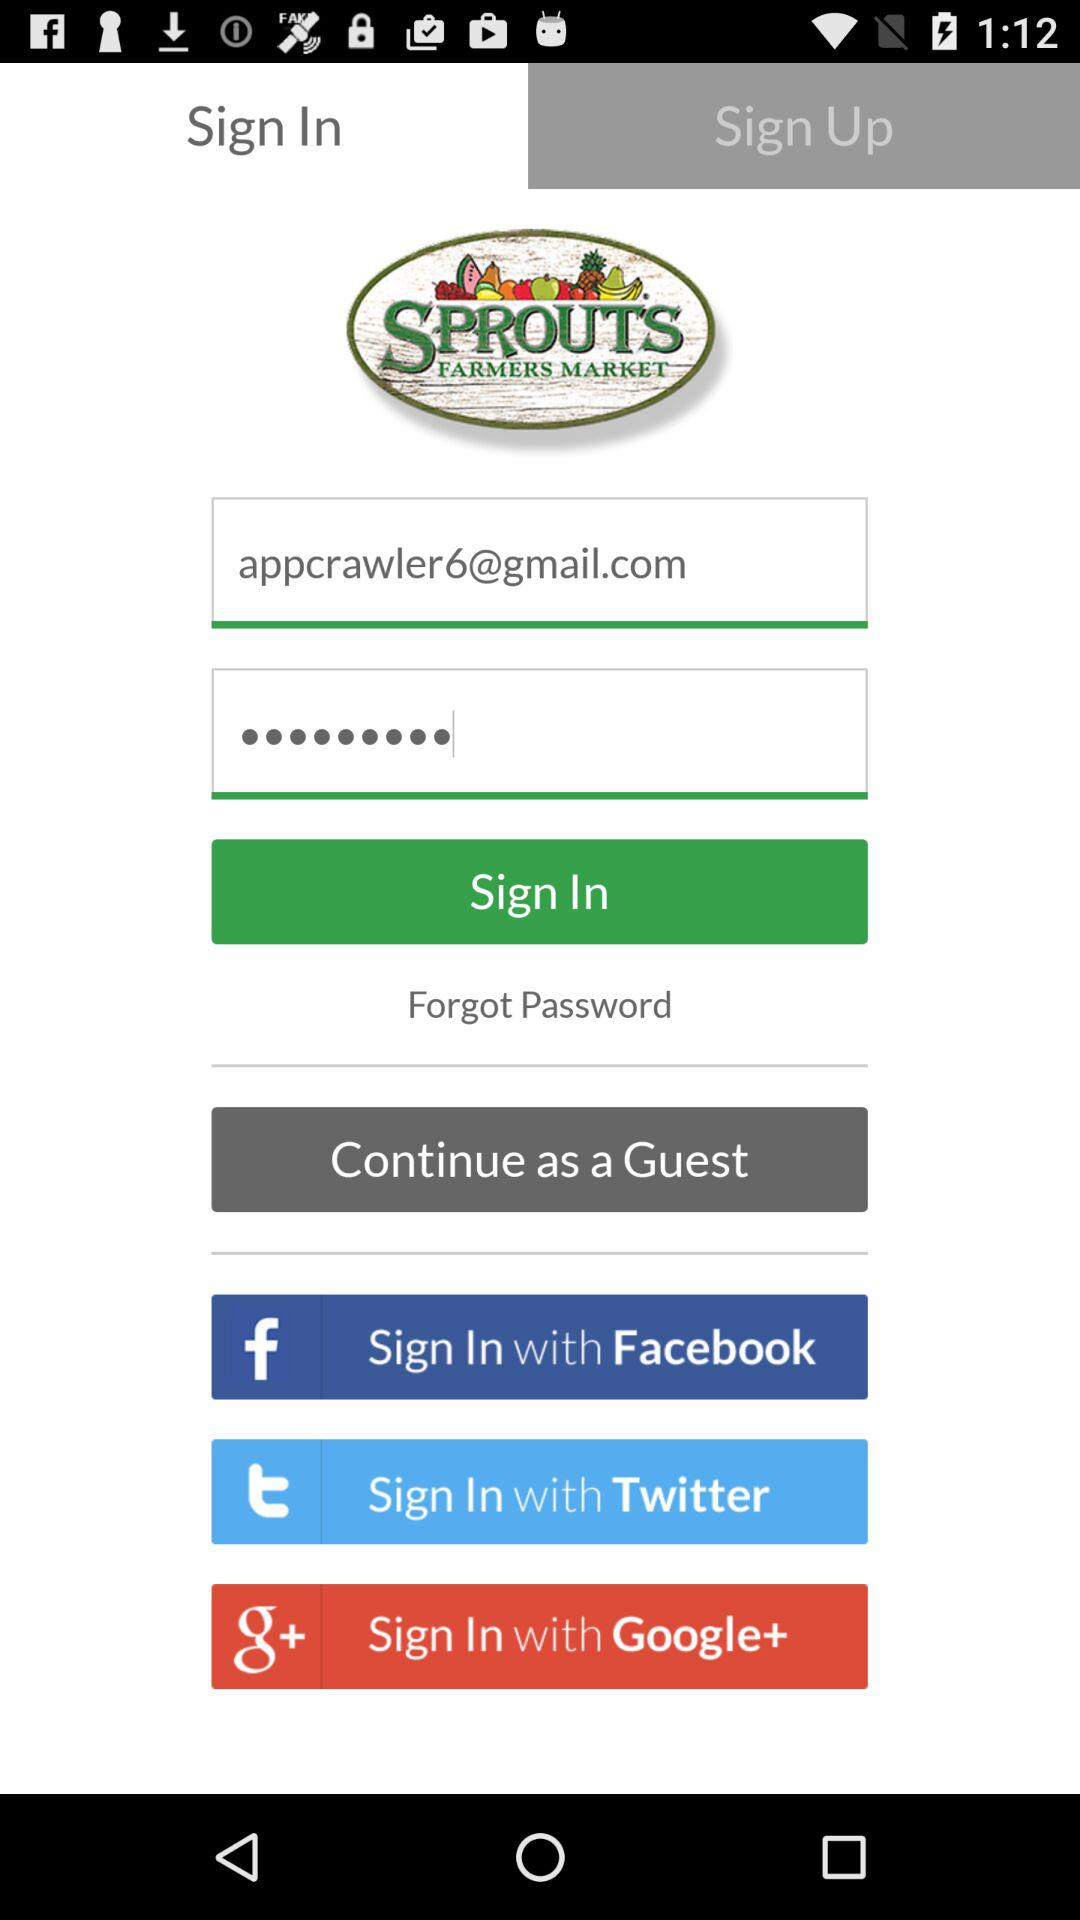Which are the different login options? The different login options are "Facebook", "Twitter" and "Google+". 